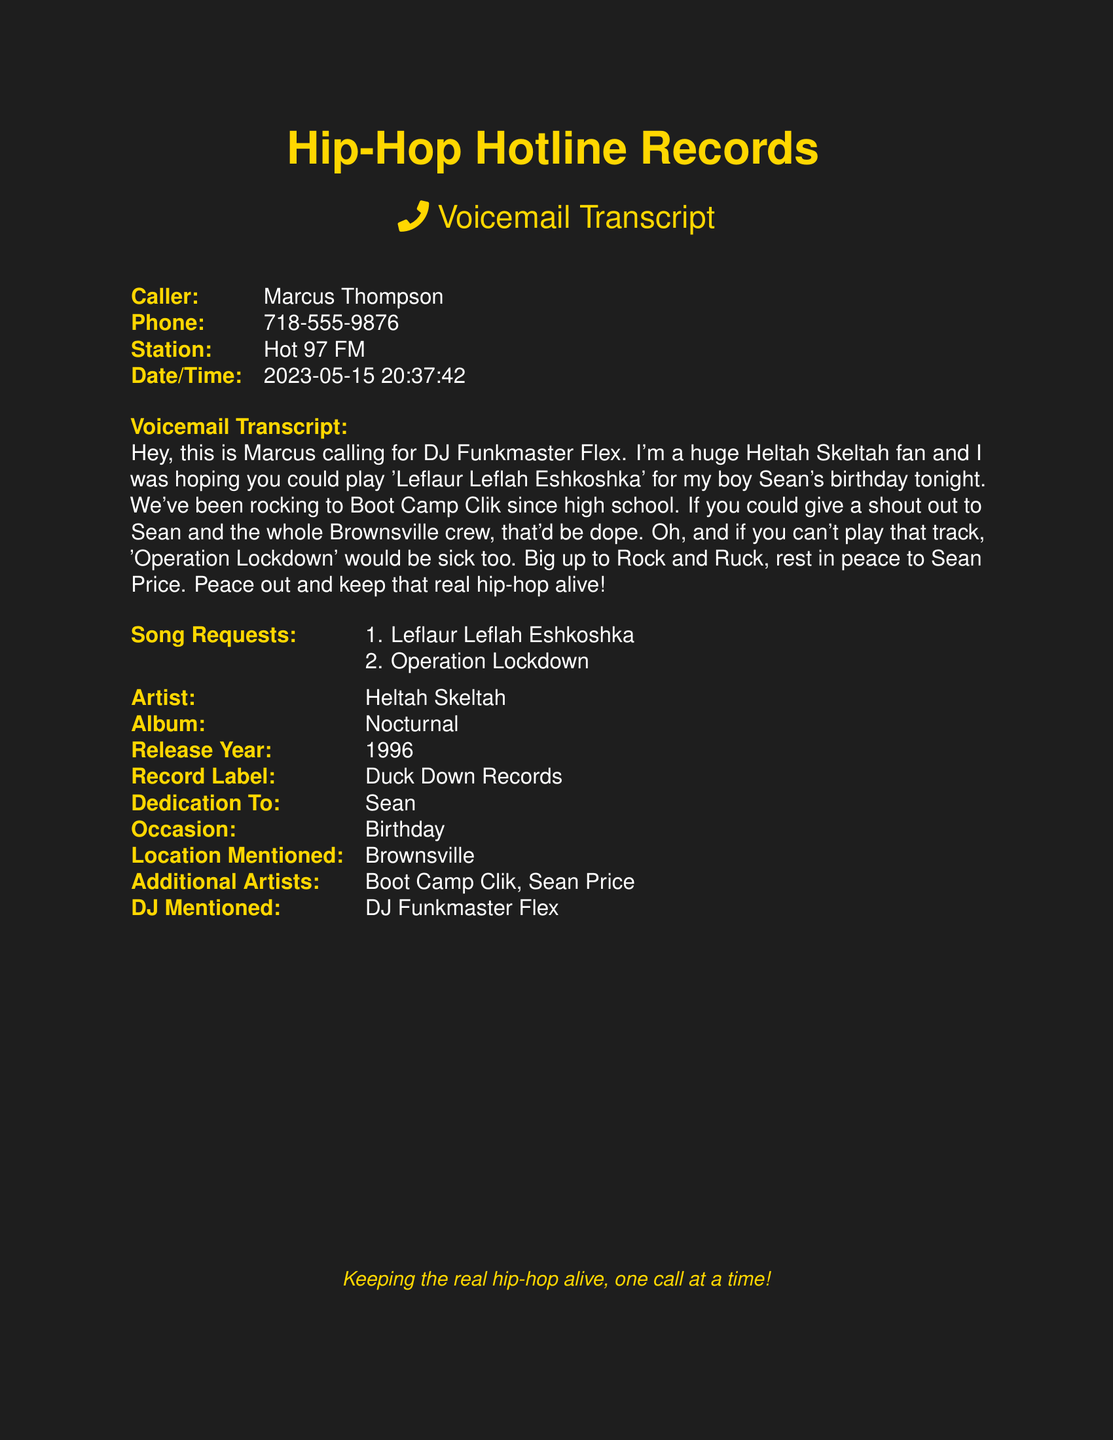What is the name of the caller? The caller's name is listed at the beginning of the voicemail transcript.
Answer: Marcus Thompson What is the phone number of the caller? The phone number is provided alongside the caller's information.
Answer: 718-555-9876 What song is requested for dedication? The requested song for the dedication is mentioned in the voicemail.
Answer: Leflaur Leflah Eshkoshka Who is the song dedication for? The dedication is specified directly within the transcript.
Answer: Sean What occasion is the dedication for? The occasion for the song dedication is indicated in the document.
Answer: Birthday What location is mentioned in the voicemail? The voicemail refers to a specific location related to the dedication.
Answer: Brownsville What additional song is suggested in case the first can't be played? The voicemail mentions an alternative song if the first choice is unavailable.
Answer: Operation Lockdown Which DJ is mentioned in the message? The voicemail specifically addresses a DJ by name.
Answer: DJ Funkmaster Flex What record label is associated with the artist? The record label affiliated with Heltah Skeltah is provided in the document.
Answer: Duck Down Records 